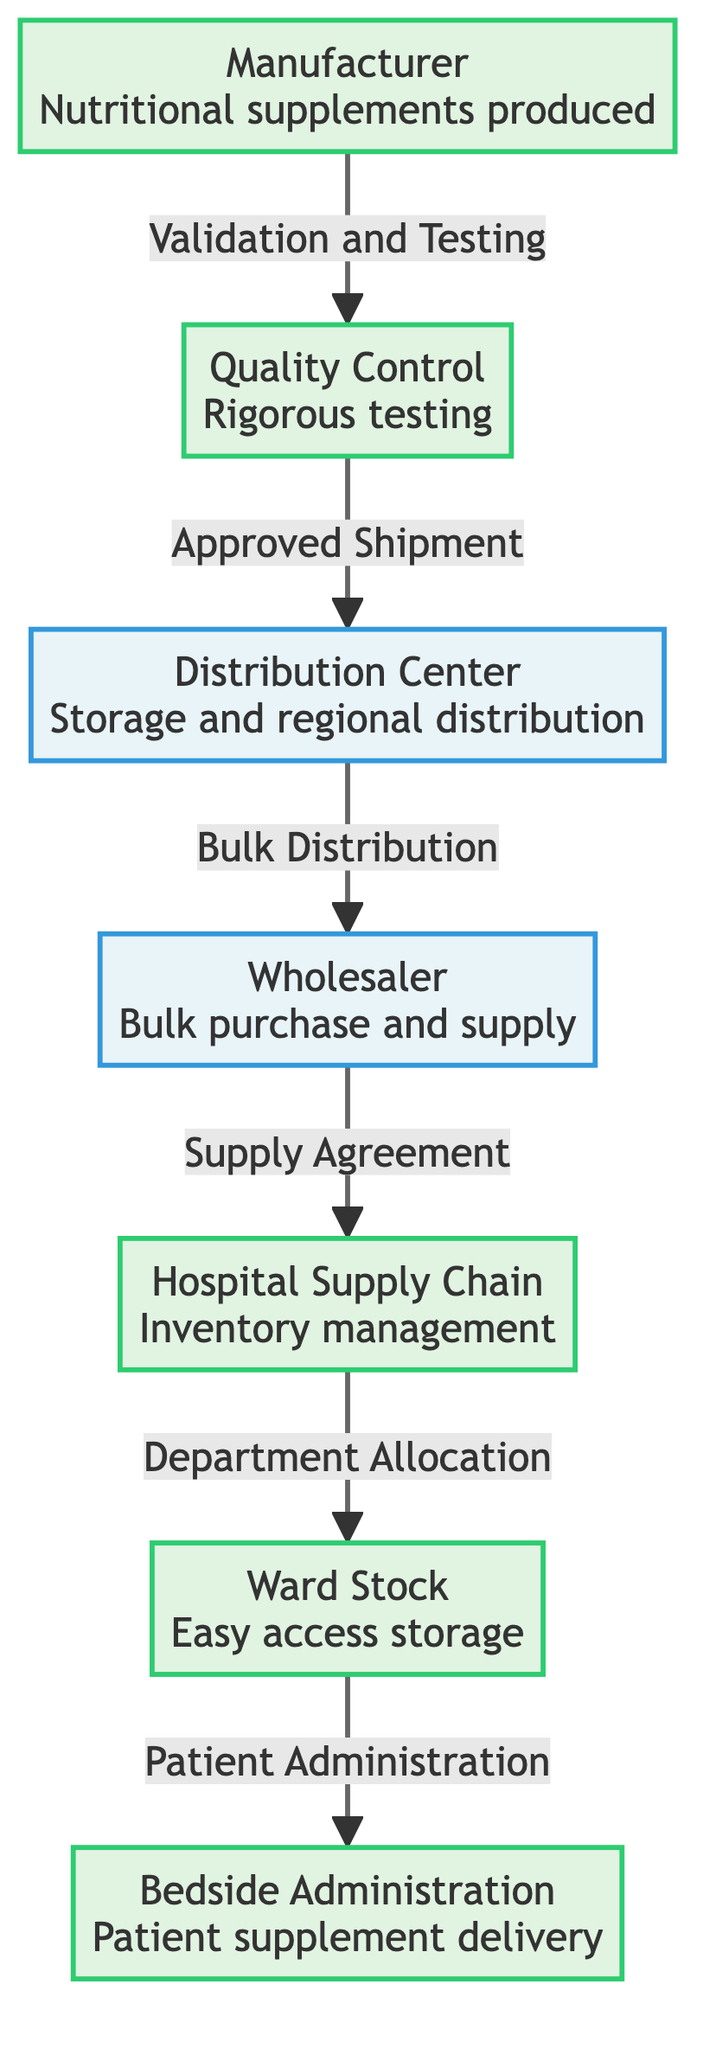What is the first step in the supply chain? The diagram indicates that the first step in the supply chain is the manufacturer, where nutritional supplements are produced.
Answer: Manufacturer How many nodes are present in the diagram? By counting each distinct process and transport node, we find there are a total of seven nodes in the diagram.
Answer: 7 What connection follows the quality control step? The diagram shows that after quality control, the approved shipment goes to the distribution center.
Answer: Distribution Center Which node is responsible for inventory management? The diagram specifies that the hospital supply chain is in charge of inventory management.
Answer: Hospital Supply Chain What type of agreement exists between the wholesaler and the hospital supply chain? The flow indicates that the type of agreement between the wholesaler and the hospital supply chain is a supply agreement.
Answer: Supply Agreement What step occurs after bulk distribution from the distribution center? After bulk distribution from the distribution center, the next step is the wholesaler, who takes on the supplied products.
Answer: Wholesaler How many steps are in the flow from manufacturer to bedside administration? The diagram outlines a sequence of five steps in the flow from manufacturer to bedside administration.
Answer: 5 What is the purpose of the ward stock? According to the diagram, the ward stock's purpose is for easy access storage of the nutritional supplements.
Answer: Easy access storage Which step directly leads to patient administration? The diagram shows that the step leading directly to patient administration is from the ward stock.
Answer: Ward Stock 